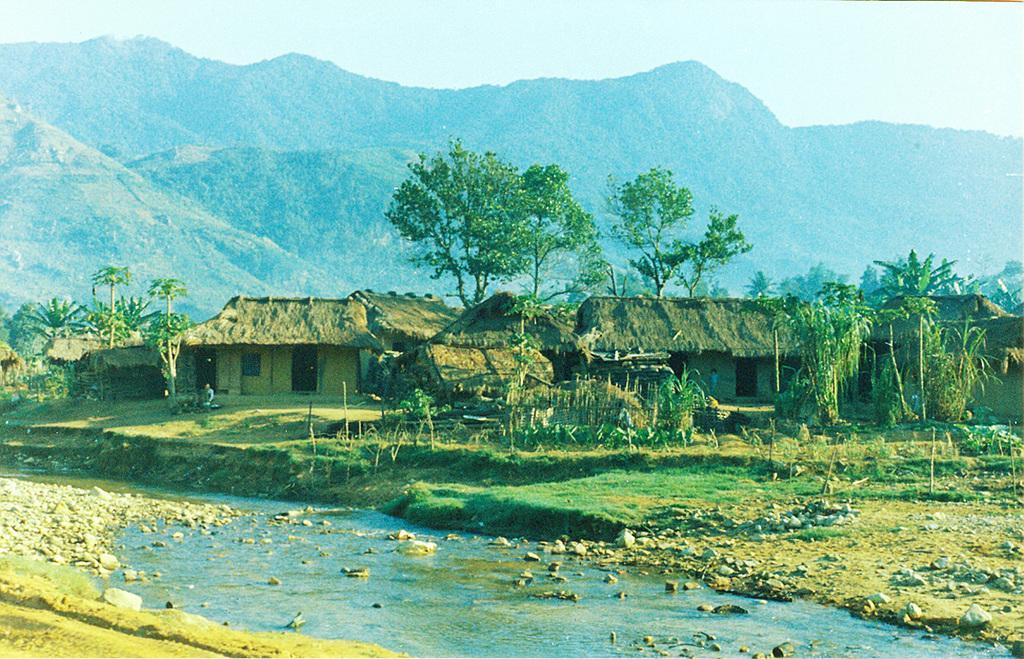Describe this image in one or two sentences. Here we can see trees, grass, houses and water. Background there is a mountain. 